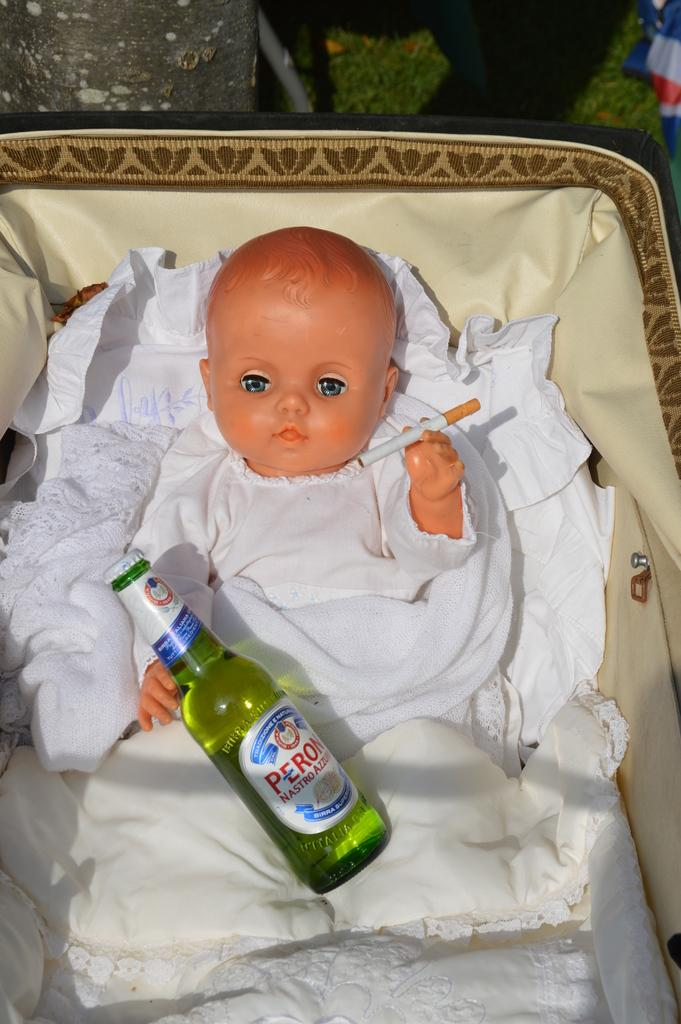What is the boy doing in the image? The boy is sitting in a chair. What object is in the boy's lap? There is a bottle in his lap. What is the boy holding in his hand? The boy is holding a cigarette. What type of paper is the boy using to shield himself from the thunder in the image? There is no paper or thunder present in the image; it only shows the boy sitting in a chair with a bottle in his lap and holding a cigarette. 